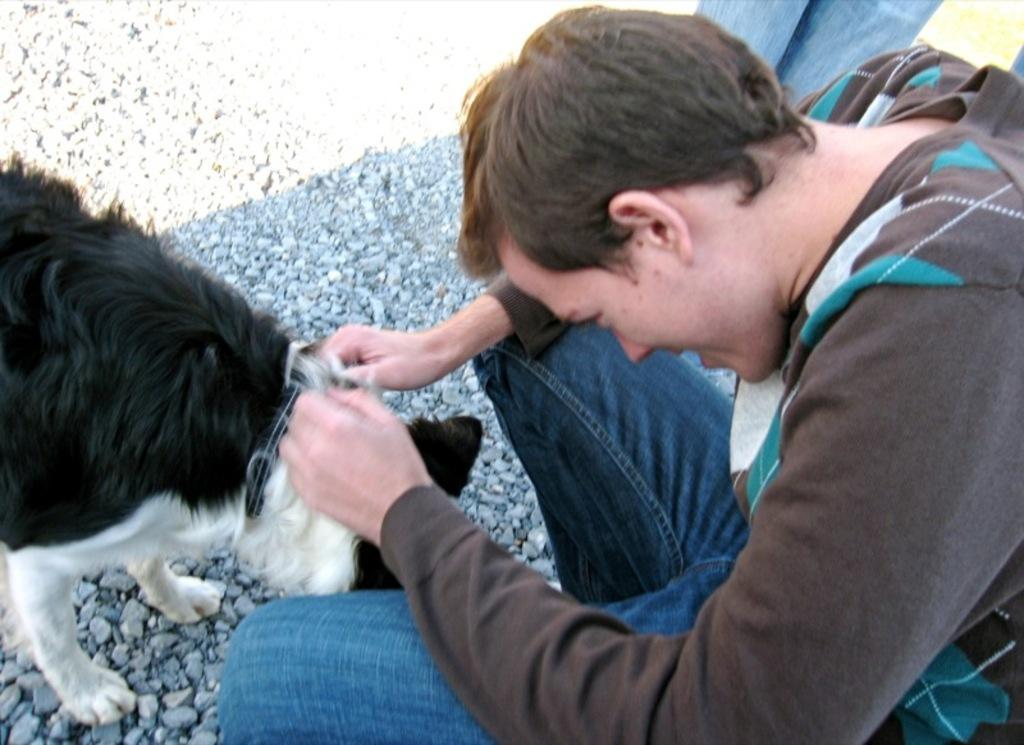What is the main subject of the image? There is a person in the image. What is the person doing in the image? The person is holding an animal. How many toads are present in the image? There is no toad present in the image; the person is holding an animal, but it is not specified as a toad. 